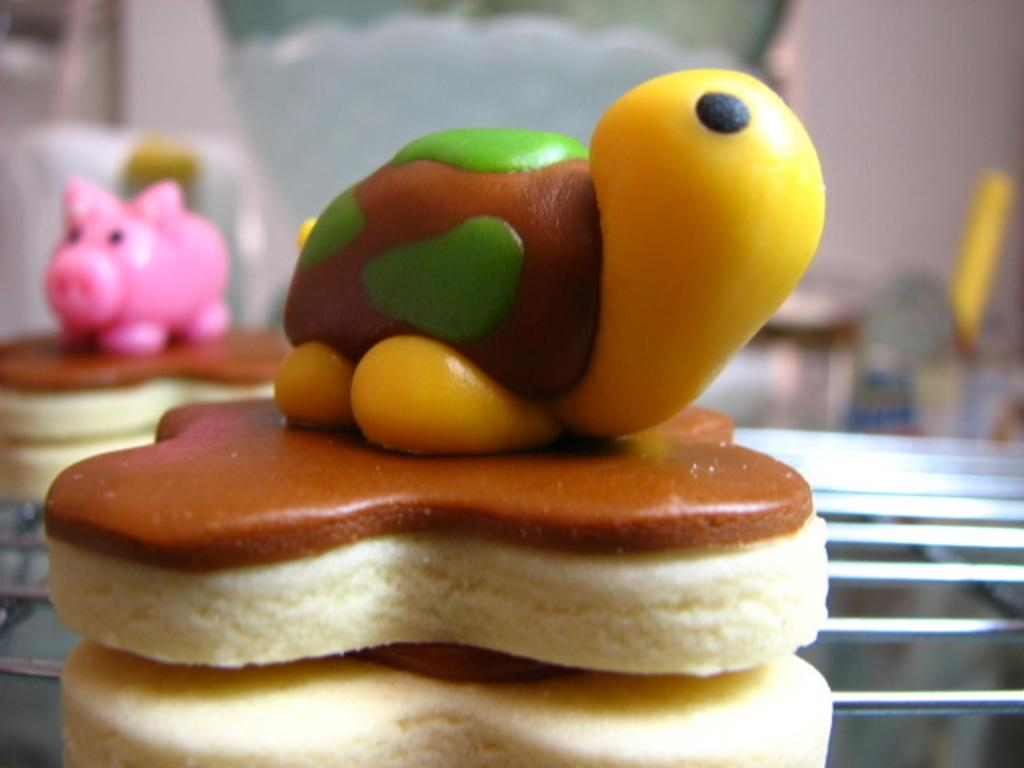What is being cooked in the image? There is food on a grill in the image. Can you describe the background of the image? The background of the image is blurry. What type of turkey can be seen in the aftermath of the party in the image? There is no turkey or party present in the image; it only shows food on a grill with a blurry background. 